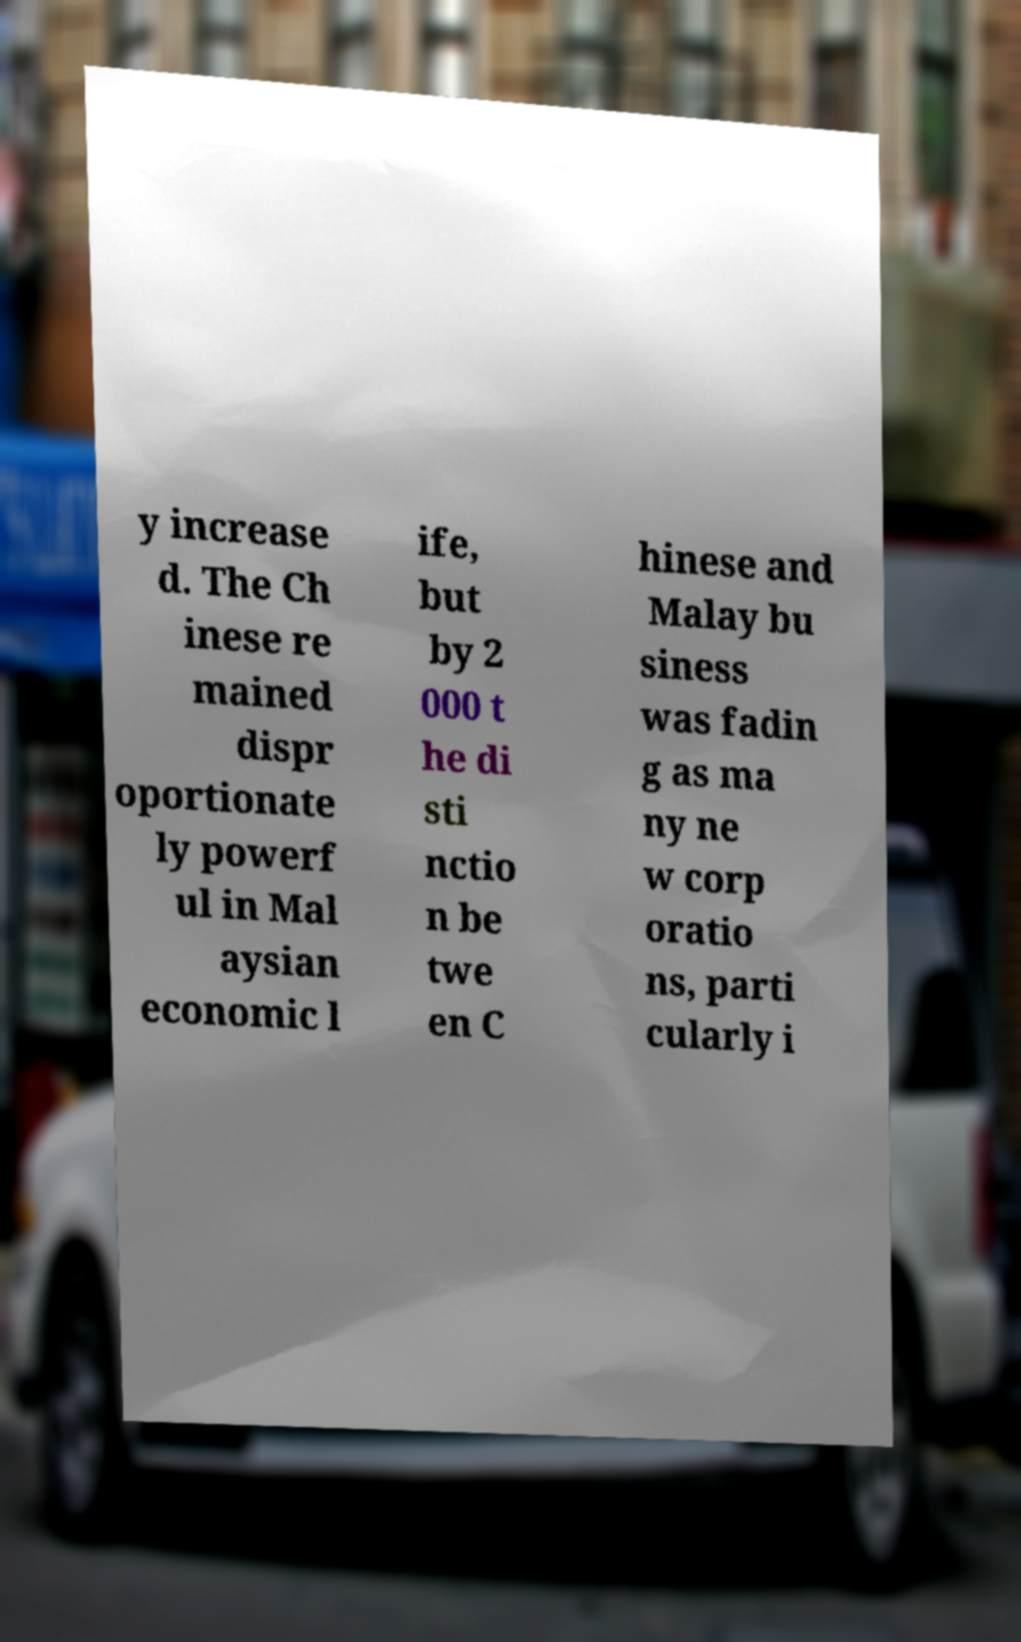Please identify and transcribe the text found in this image. y increase d. The Ch inese re mained dispr oportionate ly powerf ul in Mal aysian economic l ife, but by 2 000 t he di sti nctio n be twe en C hinese and Malay bu siness was fadin g as ma ny ne w corp oratio ns, parti cularly i 